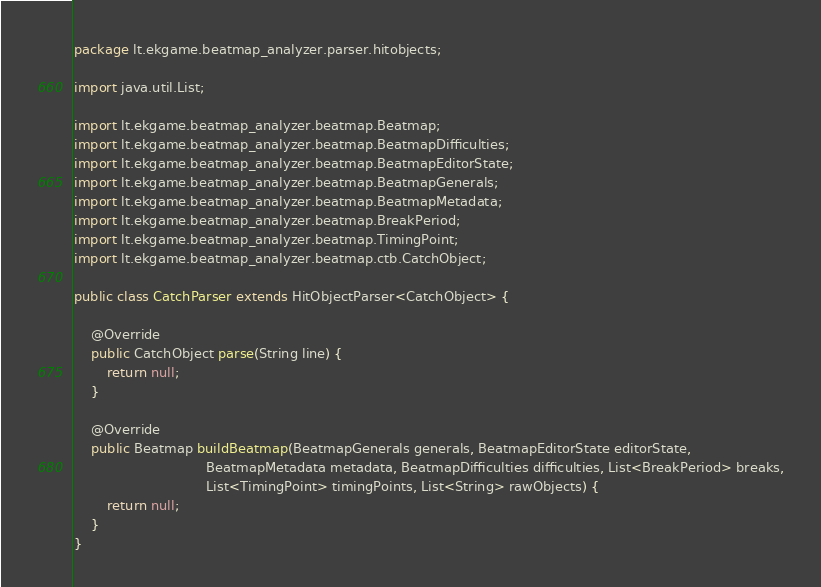<code> <loc_0><loc_0><loc_500><loc_500><_Java_>package lt.ekgame.beatmap_analyzer.parser.hitobjects;

import java.util.List;

import lt.ekgame.beatmap_analyzer.beatmap.Beatmap;
import lt.ekgame.beatmap_analyzer.beatmap.BeatmapDifficulties;
import lt.ekgame.beatmap_analyzer.beatmap.BeatmapEditorState;
import lt.ekgame.beatmap_analyzer.beatmap.BeatmapGenerals;
import lt.ekgame.beatmap_analyzer.beatmap.BeatmapMetadata;
import lt.ekgame.beatmap_analyzer.beatmap.BreakPeriod;
import lt.ekgame.beatmap_analyzer.beatmap.TimingPoint;
import lt.ekgame.beatmap_analyzer.beatmap.ctb.CatchObject;

public class CatchParser extends HitObjectParser<CatchObject> {

	@Override
	public CatchObject parse(String line) {
		return null;
	}

	@Override
	public Beatmap buildBeatmap(BeatmapGenerals generals, BeatmapEditorState editorState,
								BeatmapMetadata metadata, BeatmapDifficulties difficulties, List<BreakPeriod> breaks,
								List<TimingPoint> timingPoints, List<String> rawObjects) {
		return null;
	}
}
</code> 